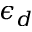Convert formula to latex. <formula><loc_0><loc_0><loc_500><loc_500>\epsilon _ { d }</formula> 